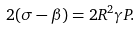Convert formula to latex. <formula><loc_0><loc_0><loc_500><loc_500>2 ( \sigma - \beta ) = 2 R ^ { 2 } \gamma P .</formula> 